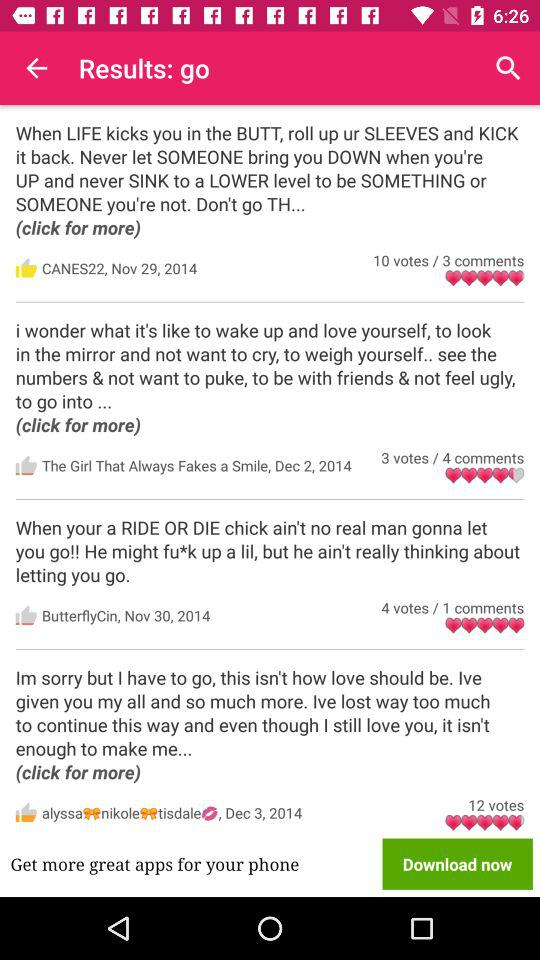How many votes does the most popular comment have?
Answer the question using a single word or phrase. 12 